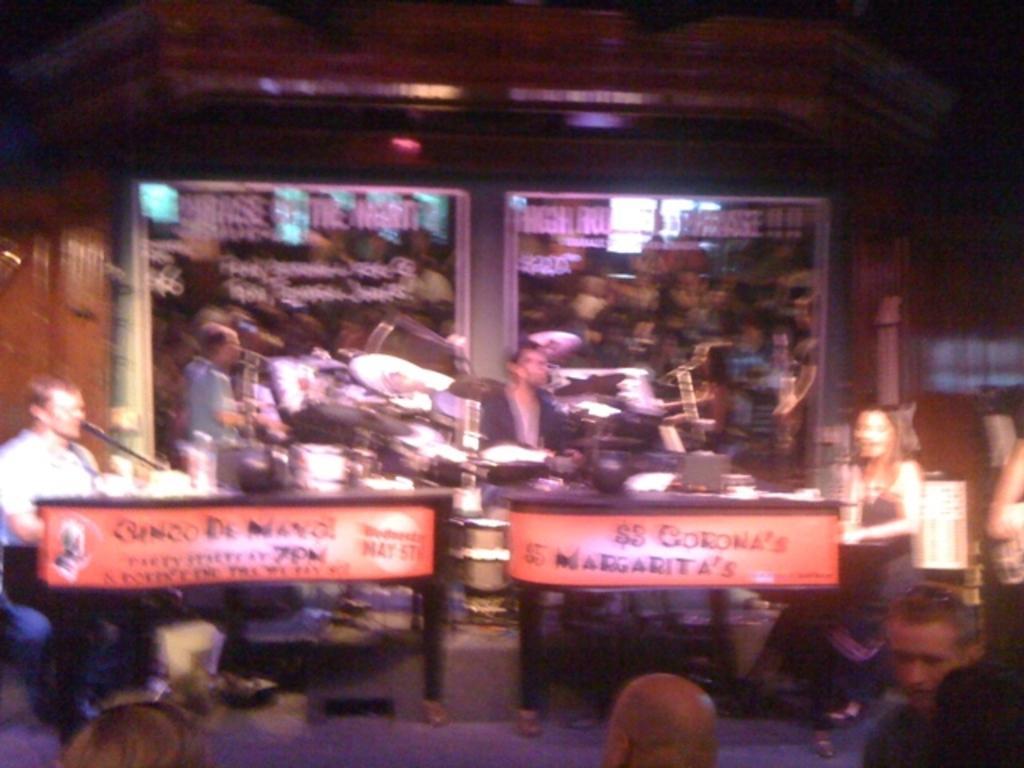Could you give a brief overview of what you see in this image? In this picture we can see some people sitting here, there is a microphone here, we can see a light and board here, in the background there is a glass and a wall. 